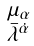Convert formula to latex. <formula><loc_0><loc_0><loc_500><loc_500>\begin{smallmatrix} \mu _ { \alpha } \\ \bar { \lambda } ^ { \dot { \alpha } } \end{smallmatrix}</formula> 